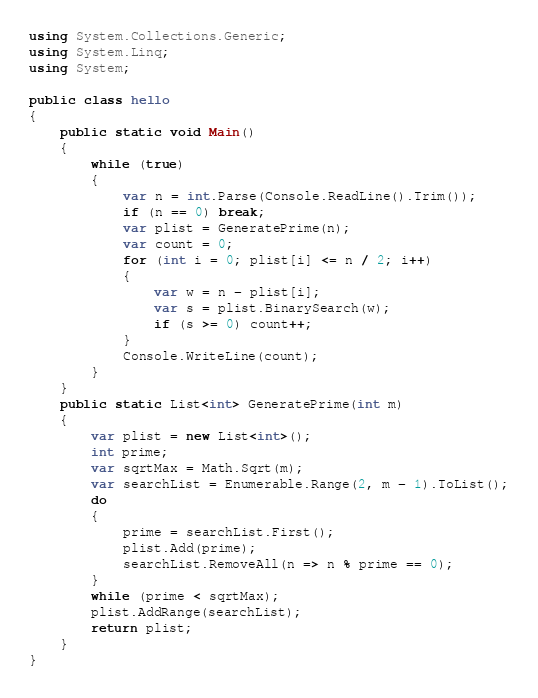Convert code to text. <code><loc_0><loc_0><loc_500><loc_500><_C#_>using System.Collections.Generic;
using System.Linq;
using System;

public class hello
{
    public static void Main()
    {
        while (true)
        {
            var n = int.Parse(Console.ReadLine().Trim());
            if (n == 0) break;
            var plist = GeneratePrime(n);
            var count = 0;
            for (int i = 0; plist[i] <= n / 2; i++)
            {
                var w = n - plist[i];
                var s = plist.BinarySearch(w);
                if (s >= 0) count++;
            }
            Console.WriteLine(count);
        }
    }
    public static List<int> GeneratePrime(int m)
    {
        var plist = new List<int>();
        int prime;
        var sqrtMax = Math.Sqrt(m);
        var searchList = Enumerable.Range(2, m - 1).ToList();
        do
        {
            prime = searchList.First();
            plist.Add(prime);
            searchList.RemoveAll(n => n % prime == 0);
        }
        while (prime < sqrtMax);
        plist.AddRange(searchList);
        return plist;
    }
}




</code> 